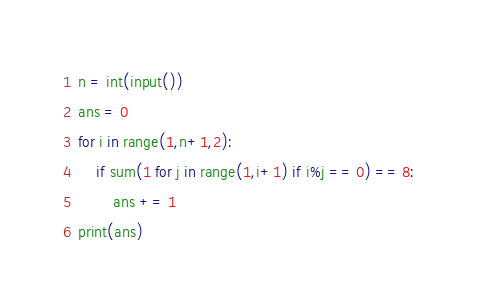Convert code to text. <code><loc_0><loc_0><loc_500><loc_500><_Python_>n = int(input())
ans = 0
for i in range(1,n+1,2):
    if sum(1 for j in range(1,i+1) if i%j == 0) == 8:
        ans += 1
print(ans)</code> 